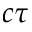<formula> <loc_0><loc_0><loc_500><loc_500>c \tau</formula> 